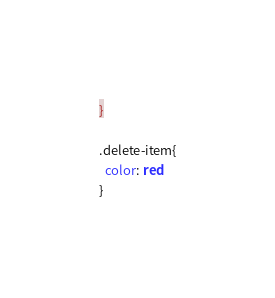Convert code to text. <code><loc_0><loc_0><loc_500><loc_500><_CSS_>}

.delete-item{
  color: red
}
</code> 